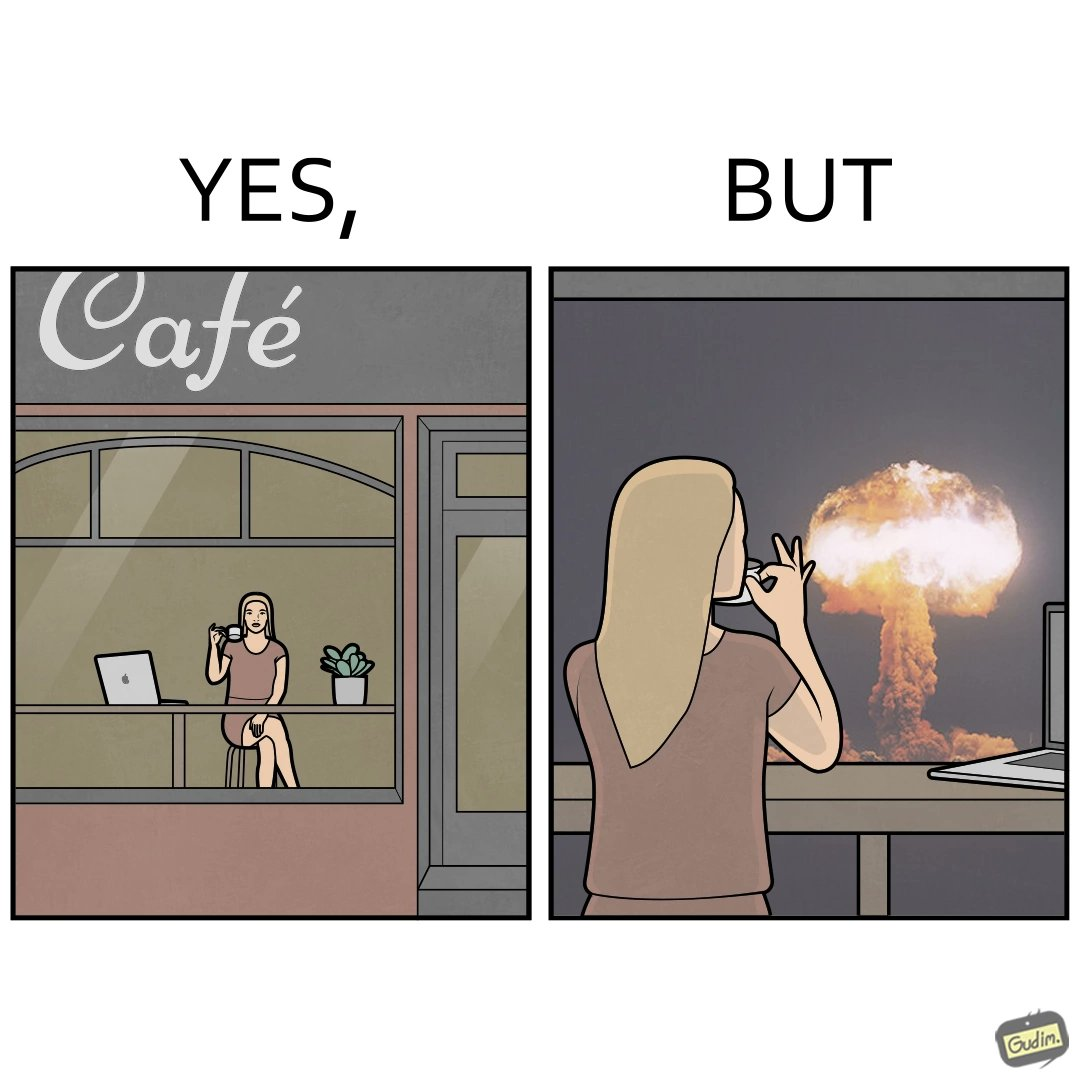Why is this image considered satirical? The images are funny since it shows a woman simply sipping from a cup at ease in a cafe with her laptop not caring about anything going on outside the cafe even though the situation is very grave,that is, a nuclear blast 